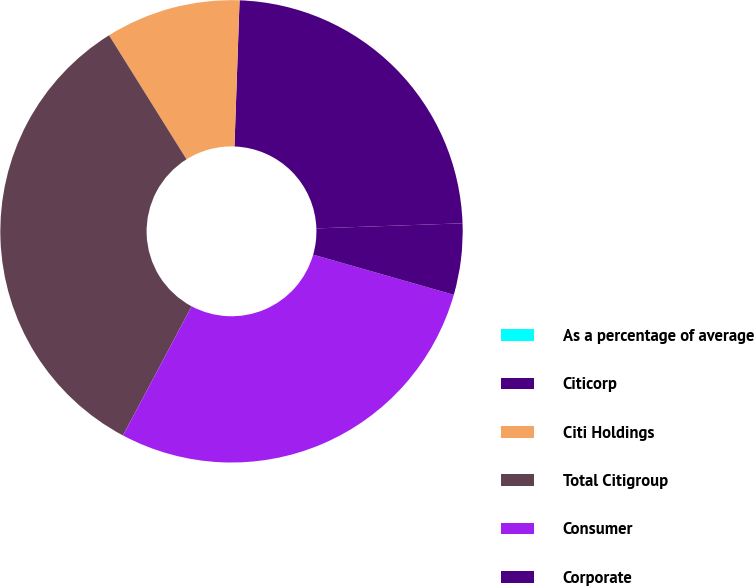Convert chart. <chart><loc_0><loc_0><loc_500><loc_500><pie_chart><fcel>As a percentage of average<fcel>Citicorp<fcel>Citi Holdings<fcel>Total Citigroup<fcel>Consumer<fcel>Corporate<nl><fcel>0.0%<fcel>23.89%<fcel>9.44%<fcel>33.33%<fcel>28.35%<fcel>4.98%<nl></chart> 